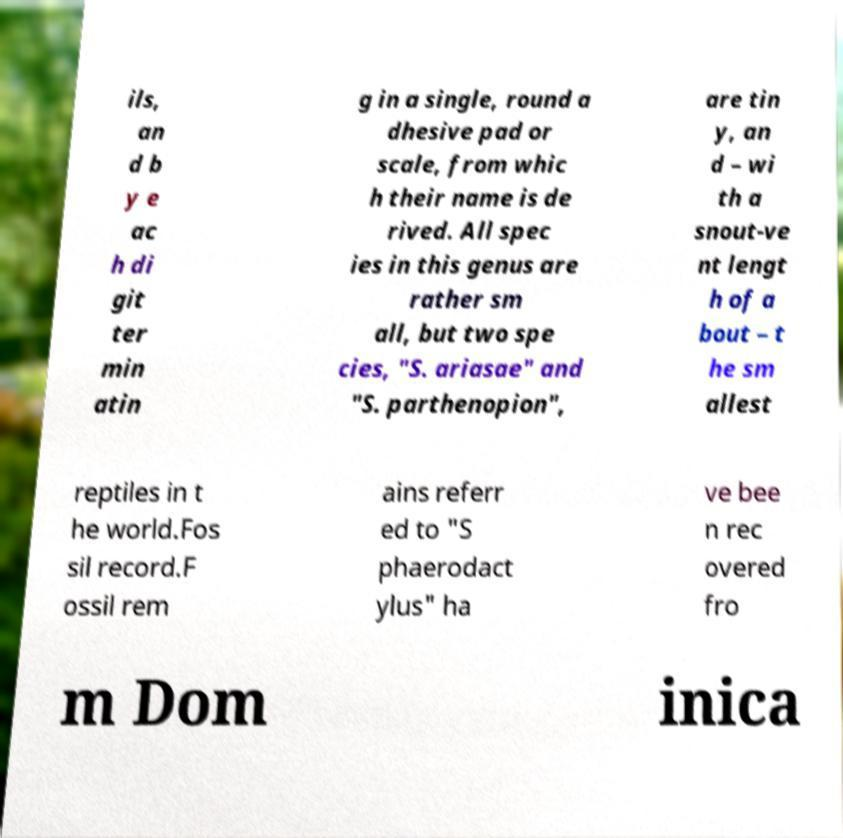Can you read and provide the text displayed in the image?This photo seems to have some interesting text. Can you extract and type it out for me? ils, an d b y e ac h di git ter min atin g in a single, round a dhesive pad or scale, from whic h their name is de rived. All spec ies in this genus are rather sm all, but two spe cies, "S. ariasae" and "S. parthenopion", are tin y, an d – wi th a snout-ve nt lengt h of a bout – t he sm allest reptiles in t he world.Fos sil record.F ossil rem ains referr ed to "S phaerodact ylus" ha ve bee n rec overed fro m Dom inica 